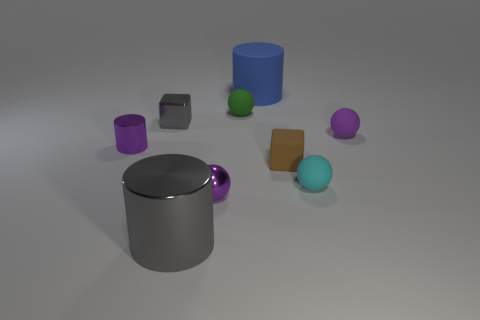Does the green rubber thing have the same size as the blue matte object to the right of the small gray shiny object?
Provide a succinct answer. No. Are there fewer small gray metallic cubes behind the large rubber thing than tiny purple balls?
Make the answer very short. Yes. How many other metallic things have the same color as the large metallic thing?
Make the answer very short. 1. Is the number of yellow metallic cubes less than the number of small shiny cubes?
Ensure brevity in your answer.  Yes. Does the blue cylinder have the same material as the tiny brown block?
Give a very brief answer. Yes. How many other objects are there of the same size as the gray shiny cylinder?
Your response must be concise. 1. The small block left of the small block in front of the small cylinder is what color?
Make the answer very short. Gray. What number of other objects are there of the same shape as the blue object?
Ensure brevity in your answer.  2. Is there a red object made of the same material as the small cyan object?
Make the answer very short. No. What is the material of the gray thing that is the same size as the blue object?
Your answer should be compact. Metal. 